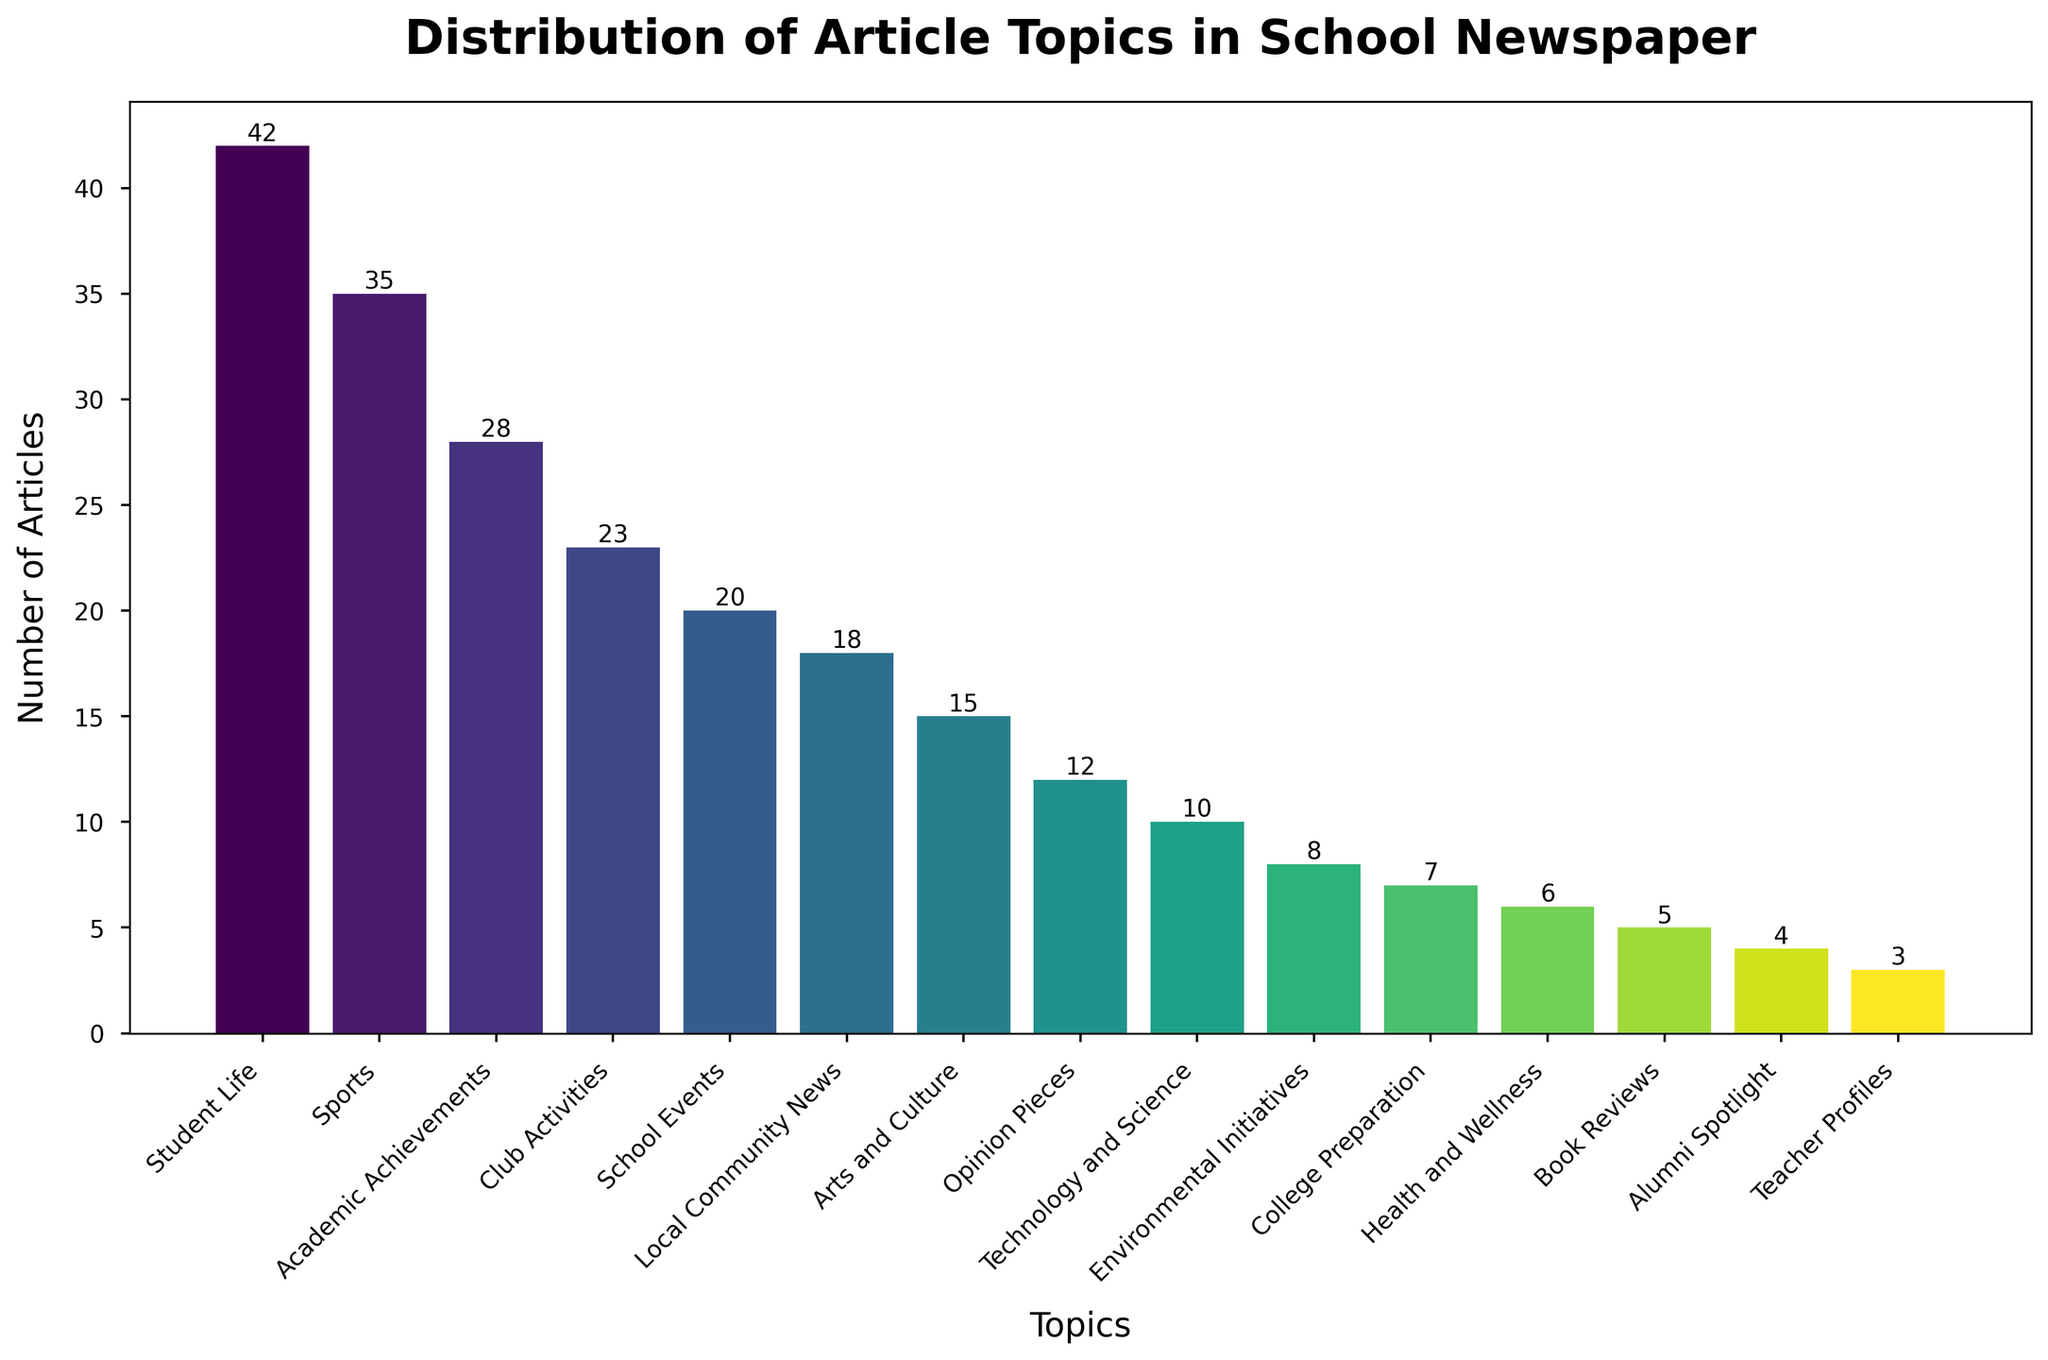What are the three topics with the highest number of articles? The three highest bars indicate the topics with the most articles: "Student Life" (42 articles), "Sports" (35 articles), and "Academic Achievements" (28 articles)
Answer: Student Life, Sports, Academic Achievements Which topic has the fewest articles? The shortest bar represents the topic with the fewest articles, which is "Teacher Profiles" (3 articles)
Answer: Teacher Profiles What is the difference in the number of articles between "Student Life" and "Technology and Science"? "Student Life" has 42 articles and "Technology and Science" has 10 articles. The difference is 42 - 10 = 32
Answer: 32 How many more articles are there on "Sports" compared to "Club Activities"? "Sports" has 35 articles whereas "Club Activities" has 23 articles. The difference is 35 - 23 = 12
Answer: 12 What is the total number of articles across all topics? Sum all the individual counts: 42 + 35 + 28 + 23 + 20 + 18 + 15 + 12 + 10 + 8 + 7 + 6 + 5 + 4 + 3 = 236
Answer: 236 Which topics have fewer than 10 articles? Bars with heights less than 10 correspond to the topics: "Environmental Initiatives" (8 articles), "College Preparation" (7 articles), "Health and Wellness" (6 articles), "Book Reviews" (5 articles), "Alumni Spotlight" (4 articles), "Teacher Profiles" (3 articles)
Answer: Environmental Initiatives, College Preparation, Health and Wellness, Book Reviews, Alumni Spotlight, Teacher Profiles Are there any topics with exactly 15 articles? Check if any bar has a height of 15. "Arts and Culture" has exactly 15 articles
Answer: Arts and Culture What is the total number of articles published on "Health and Wellness" and "Environmental Initiatives" combined? "Health and Wellness" has 6 articles and "Environmental Initiatives" has 8 articles. The total is 6 + 8 = 14
Answer: 14 How many topics have more than 20 articles each? Count the bars with heights greater than 20: "Student Life" (42), "Sports" (35), "Academic Achievements" (28), "Club Activities" (23)
Answer: 4 What is the average number of articles per topic? Total number of articles is 236. There are 15 topics. The average is 236 / 15 ≈ 15.73
Answer: 15.73 